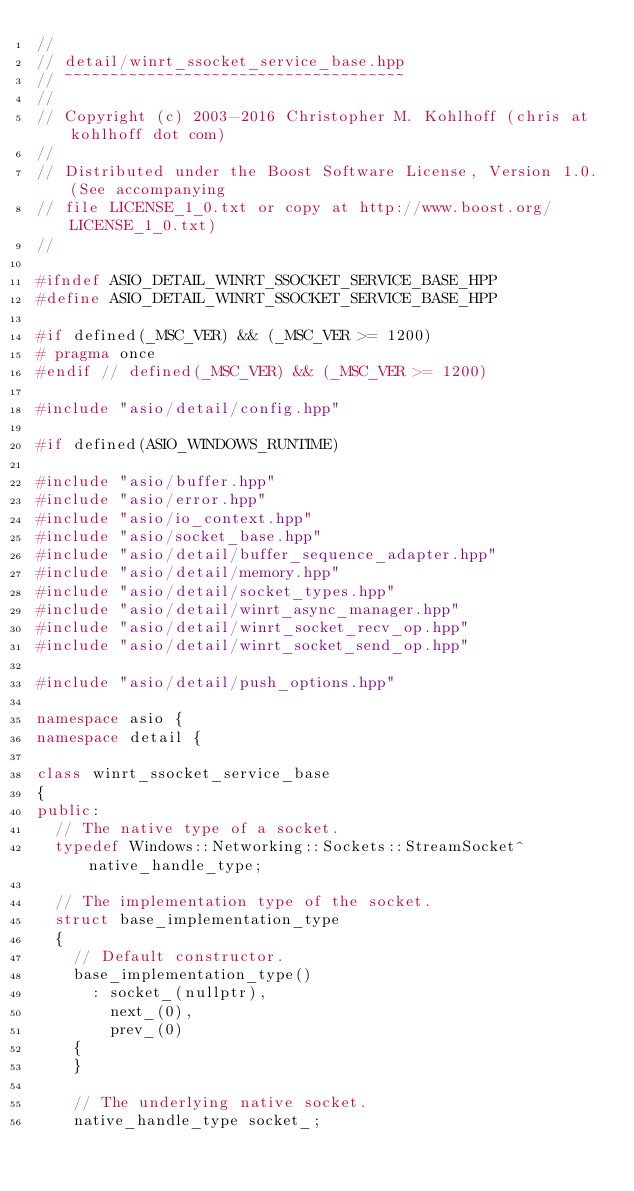Convert code to text. <code><loc_0><loc_0><loc_500><loc_500><_C++_>//
// detail/winrt_ssocket_service_base.hpp
// ~~~~~~~~~~~~~~~~~~~~~~~~~~~~~~~~~~~~~
//
// Copyright (c) 2003-2016 Christopher M. Kohlhoff (chris at kohlhoff dot com)
//
// Distributed under the Boost Software License, Version 1.0. (See accompanying
// file LICENSE_1_0.txt or copy at http://www.boost.org/LICENSE_1_0.txt)
//

#ifndef ASIO_DETAIL_WINRT_SSOCKET_SERVICE_BASE_HPP
#define ASIO_DETAIL_WINRT_SSOCKET_SERVICE_BASE_HPP

#if defined(_MSC_VER) && (_MSC_VER >= 1200)
# pragma once
#endif // defined(_MSC_VER) && (_MSC_VER >= 1200)

#include "asio/detail/config.hpp"

#if defined(ASIO_WINDOWS_RUNTIME)

#include "asio/buffer.hpp"
#include "asio/error.hpp"
#include "asio/io_context.hpp"
#include "asio/socket_base.hpp"
#include "asio/detail/buffer_sequence_adapter.hpp"
#include "asio/detail/memory.hpp"
#include "asio/detail/socket_types.hpp"
#include "asio/detail/winrt_async_manager.hpp"
#include "asio/detail/winrt_socket_recv_op.hpp"
#include "asio/detail/winrt_socket_send_op.hpp"

#include "asio/detail/push_options.hpp"

namespace asio {
namespace detail {

class winrt_ssocket_service_base
{
public:
  // The native type of a socket.
  typedef Windows::Networking::Sockets::StreamSocket^ native_handle_type;

  // The implementation type of the socket.
  struct base_implementation_type
  {
    // Default constructor.
    base_implementation_type()
      : socket_(nullptr),
        next_(0),
        prev_(0)
    {
    }

    // The underlying native socket.
    native_handle_type socket_;
</code> 